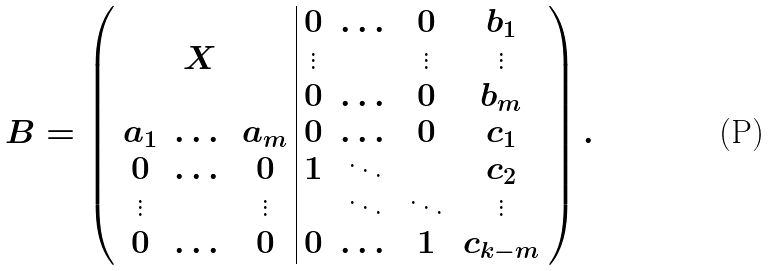<formula> <loc_0><loc_0><loc_500><loc_500>B = \left ( \begin{array} { c c c | c c c c } & & & 0 & \dots & 0 & b _ { 1 } \\ & X & & \vdots & & \vdots & \vdots \\ & & & 0 & \dots & 0 & b _ { m } \\ a _ { 1 } & \dots & a _ { m } & 0 & \dots & 0 & c _ { 1 } \\ 0 & \dots & 0 & 1 & \ddots & & c _ { 2 } \\ \vdots & & \vdots & & \ddots & \ddots & \vdots \\ 0 & \dots & 0 & 0 & \dots & 1 & c _ { k - m } \end{array} \right ) .</formula> 